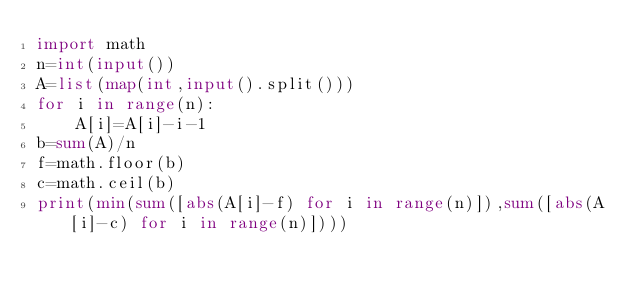<code> <loc_0><loc_0><loc_500><loc_500><_Python_>import math
n=int(input())
A=list(map(int,input().split()))
for i in range(n):
    A[i]=A[i]-i-1
b=sum(A)/n
f=math.floor(b)
c=math.ceil(b)
print(min(sum([abs(A[i]-f) for i in range(n)]),sum([abs(A[i]-c) for i in range(n)])))</code> 